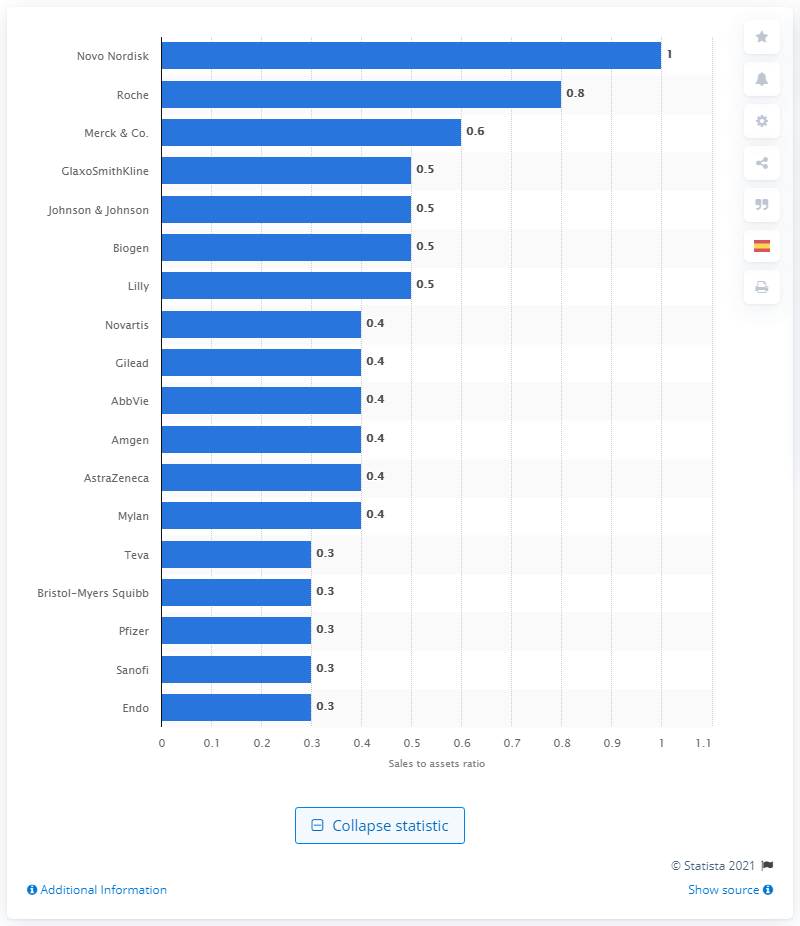Mention a couple of crucial points in this snapshot. Novo Nordisk has a sales to assets ratio of 1, which indicates that the pharmaceutical company's total sales are equivalent to its total assets. 